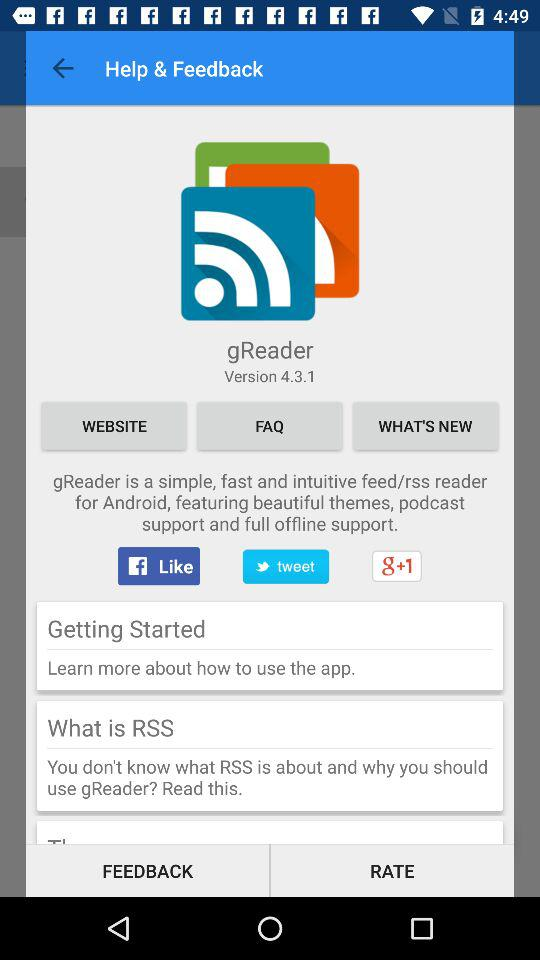What is the version? The version is 4.3.1. 